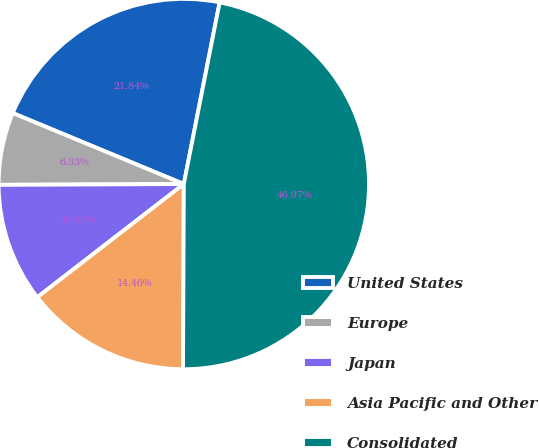Convert chart to OTSL. <chart><loc_0><loc_0><loc_500><loc_500><pie_chart><fcel>United States<fcel>Europe<fcel>Japan<fcel>Asia Pacific and Other<fcel>Consolidated<nl><fcel>21.84%<fcel>6.33%<fcel>10.4%<fcel>14.46%<fcel>46.97%<nl></chart> 